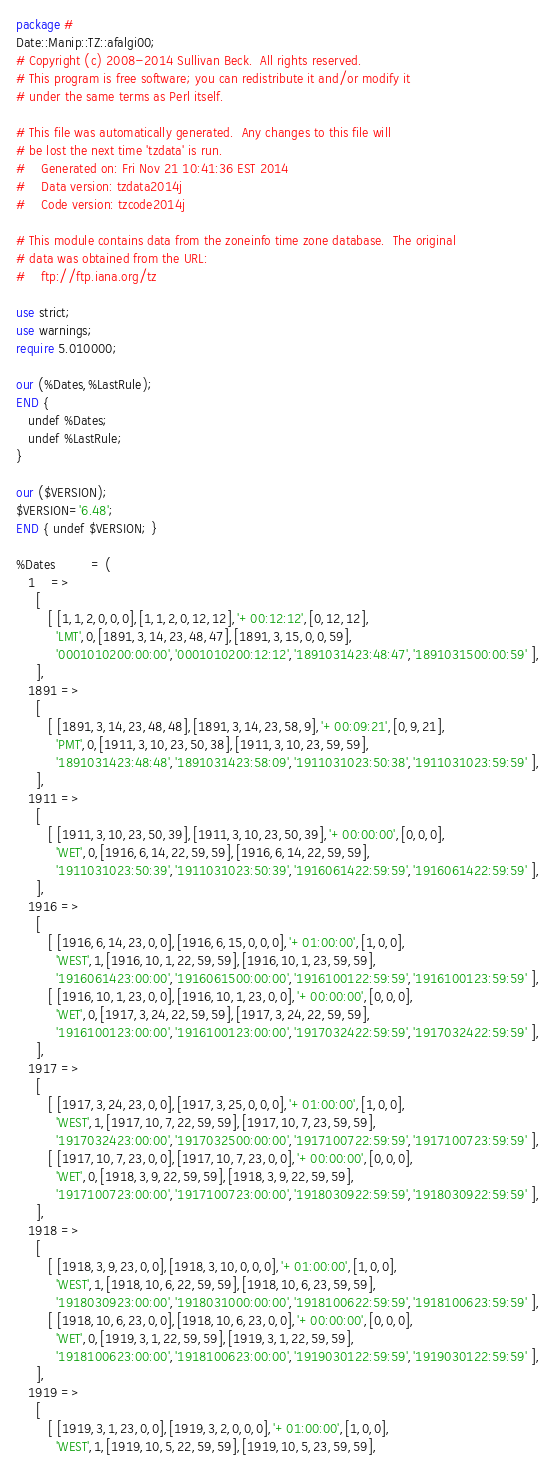<code> <loc_0><loc_0><loc_500><loc_500><_Perl_>package #
Date::Manip::TZ::afalgi00;
# Copyright (c) 2008-2014 Sullivan Beck.  All rights reserved.
# This program is free software; you can redistribute it and/or modify it
# under the same terms as Perl itself.

# This file was automatically generated.  Any changes to this file will
# be lost the next time 'tzdata' is run.
#    Generated on: Fri Nov 21 10:41:36 EST 2014
#    Data version: tzdata2014j
#    Code version: tzcode2014j

# This module contains data from the zoneinfo time zone database.  The original
# data was obtained from the URL:
#    ftp://ftp.iana.org/tz

use strict;
use warnings;
require 5.010000;

our (%Dates,%LastRule);
END {
   undef %Dates;
   undef %LastRule;
}

our ($VERSION);
$VERSION='6.48';
END { undef $VERSION; }

%Dates         = (
   1    =>
     [
        [ [1,1,2,0,0,0],[1,1,2,0,12,12],'+00:12:12',[0,12,12],
          'LMT',0,[1891,3,14,23,48,47],[1891,3,15,0,0,59],
          '0001010200:00:00','0001010200:12:12','1891031423:48:47','1891031500:00:59' ],
     ],
   1891 =>
     [
        [ [1891,3,14,23,48,48],[1891,3,14,23,58,9],'+00:09:21',[0,9,21],
          'PMT',0,[1911,3,10,23,50,38],[1911,3,10,23,59,59],
          '1891031423:48:48','1891031423:58:09','1911031023:50:38','1911031023:59:59' ],
     ],
   1911 =>
     [
        [ [1911,3,10,23,50,39],[1911,3,10,23,50,39],'+00:00:00',[0,0,0],
          'WET',0,[1916,6,14,22,59,59],[1916,6,14,22,59,59],
          '1911031023:50:39','1911031023:50:39','1916061422:59:59','1916061422:59:59' ],
     ],
   1916 =>
     [
        [ [1916,6,14,23,0,0],[1916,6,15,0,0,0],'+01:00:00',[1,0,0],
          'WEST',1,[1916,10,1,22,59,59],[1916,10,1,23,59,59],
          '1916061423:00:00','1916061500:00:00','1916100122:59:59','1916100123:59:59' ],
        [ [1916,10,1,23,0,0],[1916,10,1,23,0,0],'+00:00:00',[0,0,0],
          'WET',0,[1917,3,24,22,59,59],[1917,3,24,22,59,59],
          '1916100123:00:00','1916100123:00:00','1917032422:59:59','1917032422:59:59' ],
     ],
   1917 =>
     [
        [ [1917,3,24,23,0,0],[1917,3,25,0,0,0],'+01:00:00',[1,0,0],
          'WEST',1,[1917,10,7,22,59,59],[1917,10,7,23,59,59],
          '1917032423:00:00','1917032500:00:00','1917100722:59:59','1917100723:59:59' ],
        [ [1917,10,7,23,0,0],[1917,10,7,23,0,0],'+00:00:00',[0,0,0],
          'WET',0,[1918,3,9,22,59,59],[1918,3,9,22,59,59],
          '1917100723:00:00','1917100723:00:00','1918030922:59:59','1918030922:59:59' ],
     ],
   1918 =>
     [
        [ [1918,3,9,23,0,0],[1918,3,10,0,0,0],'+01:00:00',[1,0,0],
          'WEST',1,[1918,10,6,22,59,59],[1918,10,6,23,59,59],
          '1918030923:00:00','1918031000:00:00','1918100622:59:59','1918100623:59:59' ],
        [ [1918,10,6,23,0,0],[1918,10,6,23,0,0],'+00:00:00',[0,0,0],
          'WET',0,[1919,3,1,22,59,59],[1919,3,1,22,59,59],
          '1918100623:00:00','1918100623:00:00','1919030122:59:59','1919030122:59:59' ],
     ],
   1919 =>
     [
        [ [1919,3,1,23,0,0],[1919,3,2,0,0,0],'+01:00:00',[1,0,0],
          'WEST',1,[1919,10,5,22,59,59],[1919,10,5,23,59,59],</code> 